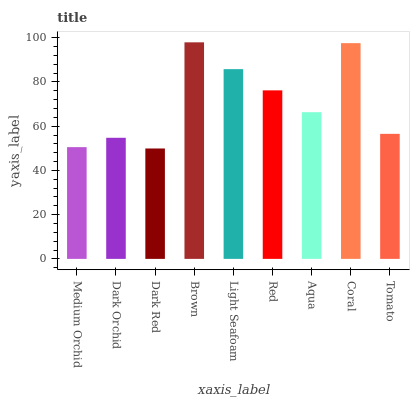Is Dark Orchid the minimum?
Answer yes or no. No. Is Dark Orchid the maximum?
Answer yes or no. No. Is Dark Orchid greater than Medium Orchid?
Answer yes or no. Yes. Is Medium Orchid less than Dark Orchid?
Answer yes or no. Yes. Is Medium Orchid greater than Dark Orchid?
Answer yes or no. No. Is Dark Orchid less than Medium Orchid?
Answer yes or no. No. Is Aqua the high median?
Answer yes or no. Yes. Is Aqua the low median?
Answer yes or no. Yes. Is Medium Orchid the high median?
Answer yes or no. No. Is Tomato the low median?
Answer yes or no. No. 